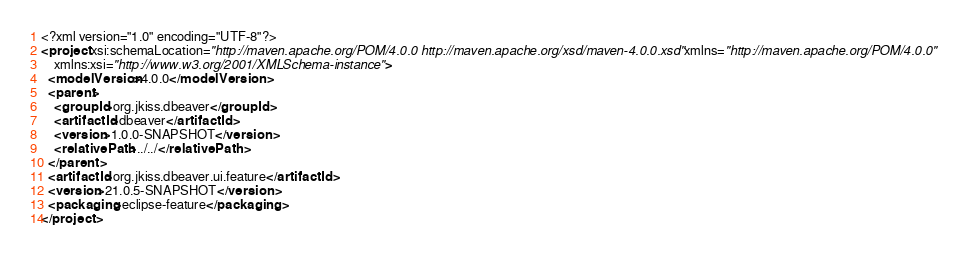Convert code to text. <code><loc_0><loc_0><loc_500><loc_500><_XML_><?xml version="1.0" encoding="UTF-8"?>
<project xsi:schemaLocation="http://maven.apache.org/POM/4.0.0 http://maven.apache.org/xsd/maven-4.0.0.xsd" xmlns="http://maven.apache.org/POM/4.0.0"
    xmlns:xsi="http://www.w3.org/2001/XMLSchema-instance">
  <modelVersion>4.0.0</modelVersion>
  <parent>
    <groupId>org.jkiss.dbeaver</groupId>
    <artifactId>dbeaver</artifactId>
    <version>1.0.0-SNAPSHOT</version>
    <relativePath>../../</relativePath>
  </parent>
  <artifactId>org.jkiss.dbeaver.ui.feature</artifactId>
  <version>21.0.5-SNAPSHOT</version>
  <packaging>eclipse-feature</packaging>
</project>
</code> 